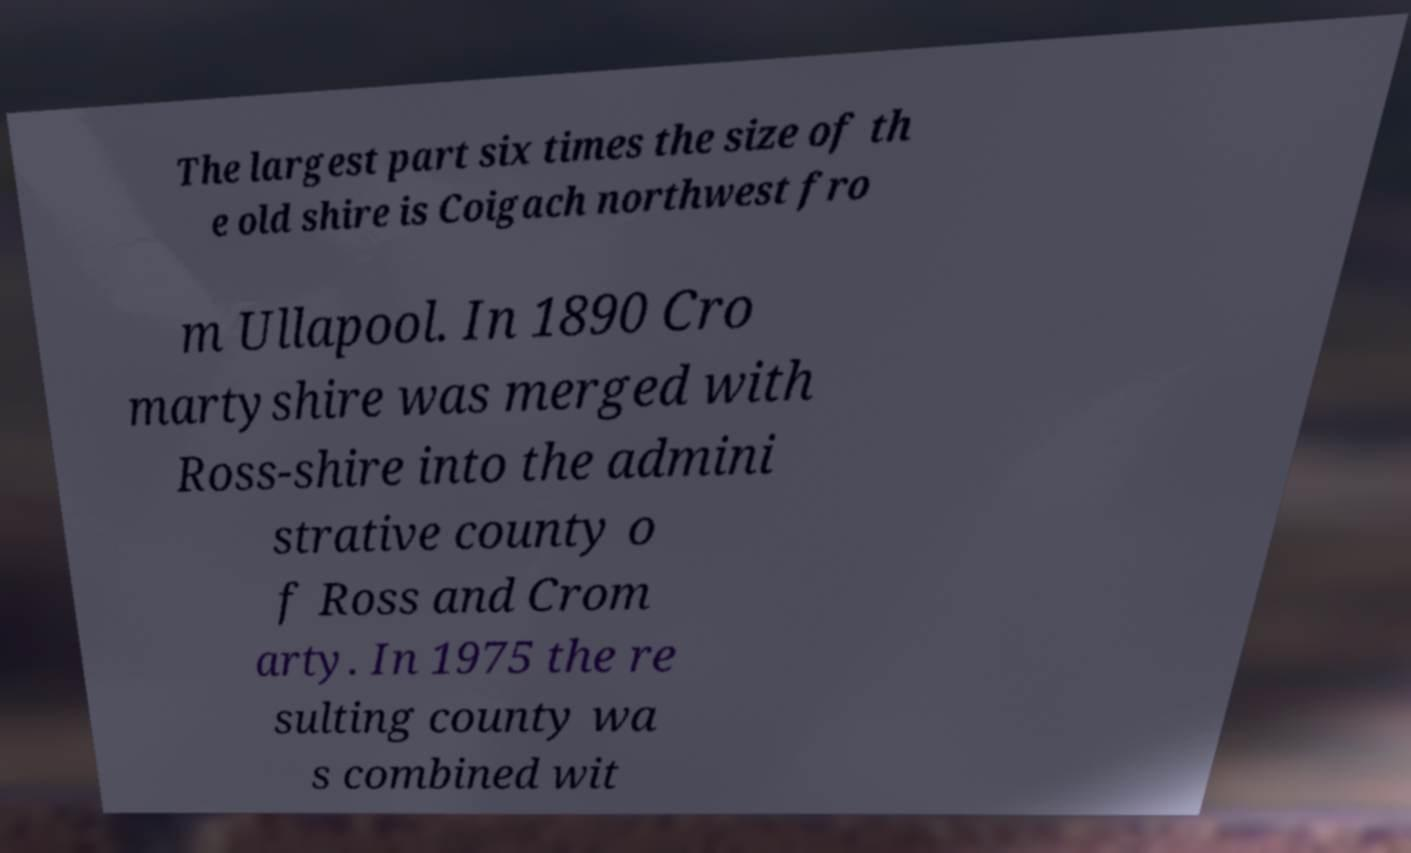Could you extract and type out the text from this image? The largest part six times the size of th e old shire is Coigach northwest fro m Ullapool. In 1890 Cro martyshire was merged with Ross-shire into the admini strative county o f Ross and Crom arty. In 1975 the re sulting county wa s combined wit 